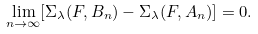<formula> <loc_0><loc_0><loc_500><loc_500>\lim _ { n \rightarrow \infty } [ \Sigma _ { \lambda } ( F , B _ { n } ) - \Sigma _ { \lambda } ( F , A _ { n } ) ] = 0 .</formula> 